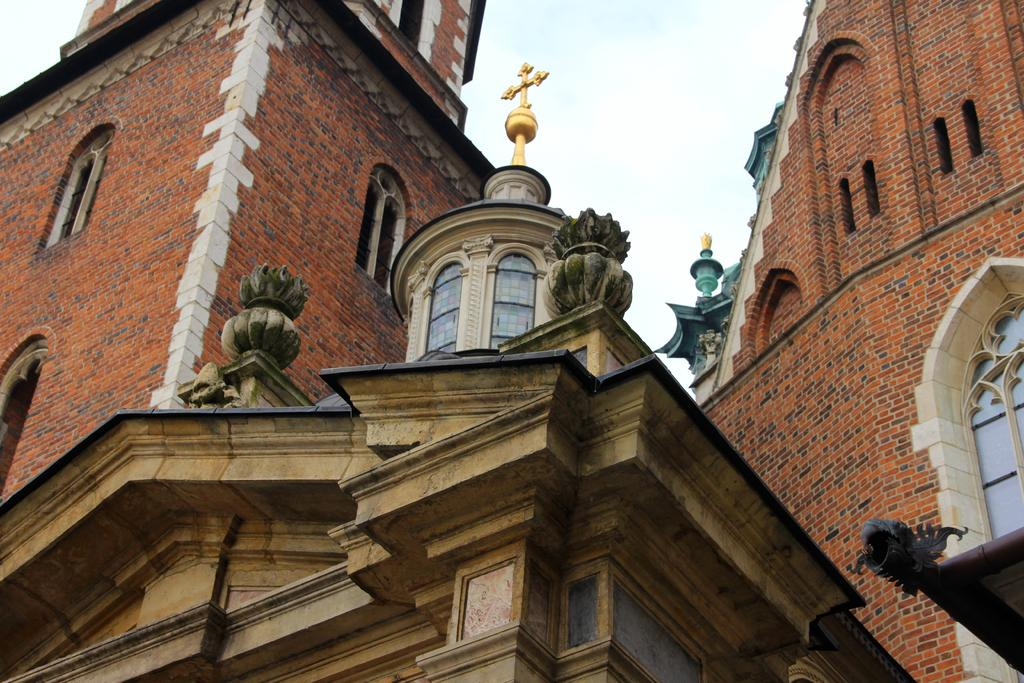What is the main subject of the picture? The main subject of the picture is a building. What specific features can be observed on the building? The building has windows. What can be seen in the background of the picture? The sky is visible in the background of the picture. What language is spoken by the people in the town depicted in the image? There is no town or people present in the image; it only features a building and the sky. How many baths are visible in the image? There are no baths present in the image. 